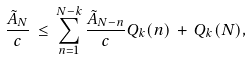Convert formula to latex. <formula><loc_0><loc_0><loc_500><loc_500>\frac { \tilde { A } _ { N } } c \, \leq \, \sum _ { n = 1 } ^ { N - k } \frac { \tilde { A } _ { N - n } } c Q _ { k } ( n ) \, + \, Q _ { k } ( N ) ,</formula> 